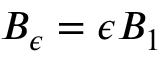Convert formula to latex. <formula><loc_0><loc_0><loc_500><loc_500>B _ { \epsilon } = \epsilon B _ { 1 }</formula> 